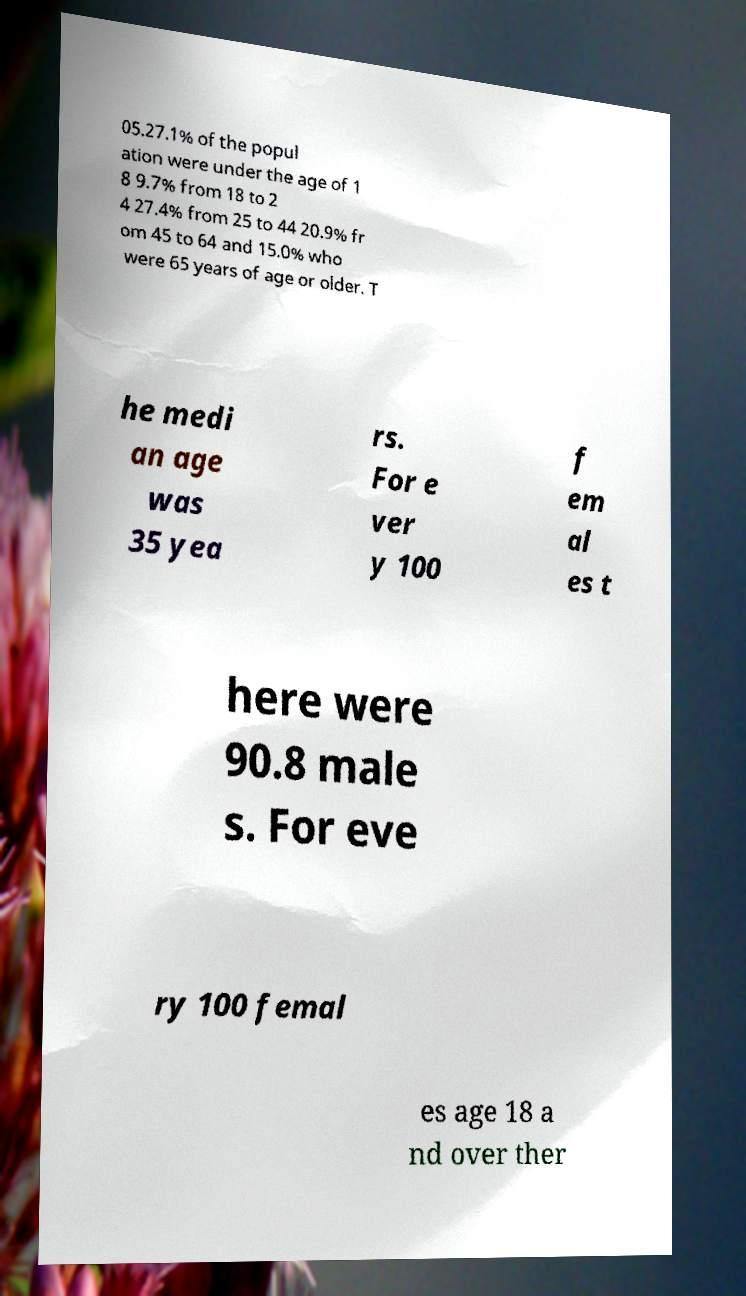Can you read and provide the text displayed in the image?This photo seems to have some interesting text. Can you extract and type it out for me? 05.27.1% of the popul ation were under the age of 1 8 9.7% from 18 to 2 4 27.4% from 25 to 44 20.9% fr om 45 to 64 and 15.0% who were 65 years of age or older. T he medi an age was 35 yea rs. For e ver y 100 f em al es t here were 90.8 male s. For eve ry 100 femal es age 18 a nd over ther 